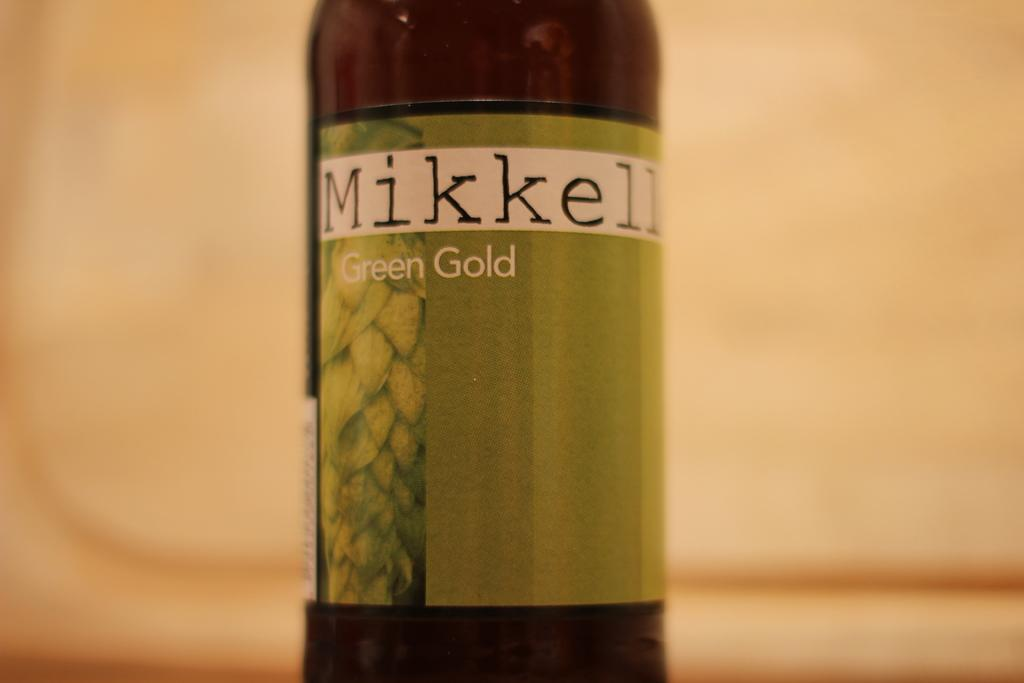Provide a one-sentence caption for the provided image. A bottle for Mikkell Green Gold beverage stands out against a creamy beige background. 